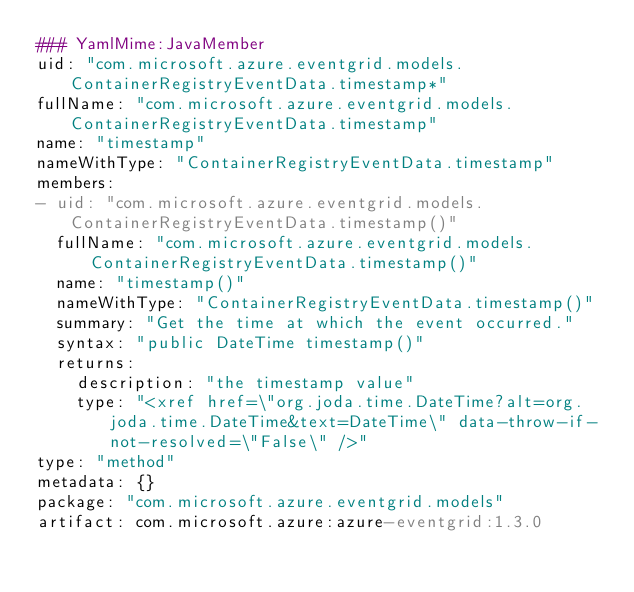Convert code to text. <code><loc_0><loc_0><loc_500><loc_500><_YAML_>### YamlMime:JavaMember
uid: "com.microsoft.azure.eventgrid.models.ContainerRegistryEventData.timestamp*"
fullName: "com.microsoft.azure.eventgrid.models.ContainerRegistryEventData.timestamp"
name: "timestamp"
nameWithType: "ContainerRegistryEventData.timestamp"
members:
- uid: "com.microsoft.azure.eventgrid.models.ContainerRegistryEventData.timestamp()"
  fullName: "com.microsoft.azure.eventgrid.models.ContainerRegistryEventData.timestamp()"
  name: "timestamp()"
  nameWithType: "ContainerRegistryEventData.timestamp()"
  summary: "Get the time at which the event occurred."
  syntax: "public DateTime timestamp()"
  returns:
    description: "the timestamp value"
    type: "<xref href=\"org.joda.time.DateTime?alt=org.joda.time.DateTime&text=DateTime\" data-throw-if-not-resolved=\"False\" />"
type: "method"
metadata: {}
package: "com.microsoft.azure.eventgrid.models"
artifact: com.microsoft.azure:azure-eventgrid:1.3.0
</code> 